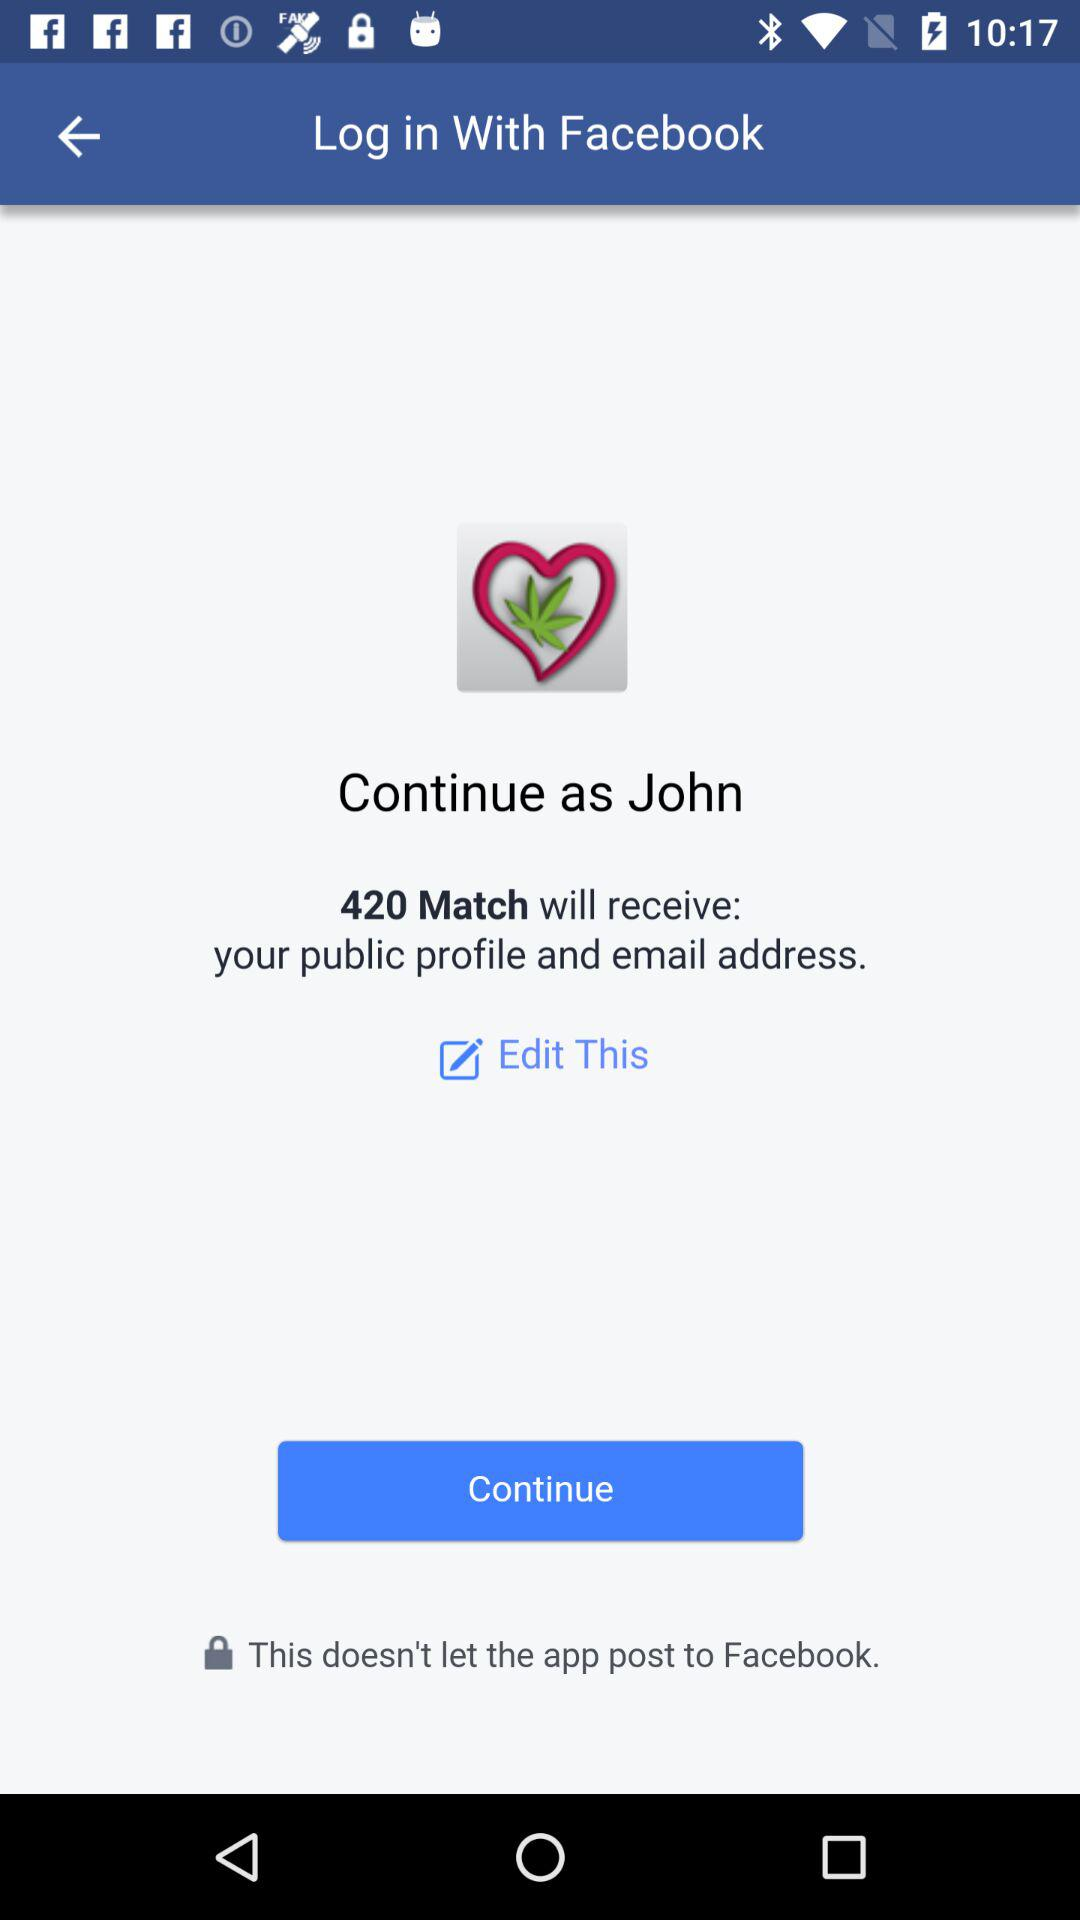What application is used to log in? The application used to log in is "Facebook". 